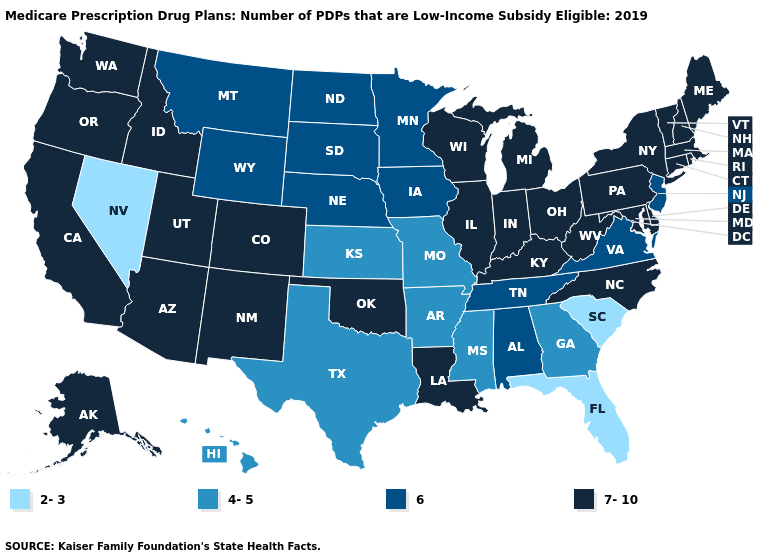What is the value of North Dakota?
Be succinct. 6. How many symbols are there in the legend?
Answer briefly. 4. What is the value of Rhode Island?
Be succinct. 7-10. Among the states that border Florida , which have the lowest value?
Quick response, please. Georgia. Does Maryland have the lowest value in the South?
Write a very short answer. No. How many symbols are there in the legend?
Keep it brief. 4. What is the value of Wyoming?
Give a very brief answer. 6. What is the value of Iowa?
Be succinct. 6. What is the lowest value in the USA?
Quick response, please. 2-3. Name the states that have a value in the range 4-5?
Concise answer only. Arkansas, Georgia, Hawaii, Kansas, Mississippi, Missouri, Texas. Which states have the lowest value in the MidWest?
Answer briefly. Kansas, Missouri. Among the states that border Maine , which have the lowest value?
Keep it brief. New Hampshire. Name the states that have a value in the range 2-3?
Short answer required. Florida, Nevada, South Carolina. Does Wisconsin have the highest value in the USA?
Answer briefly. Yes. 